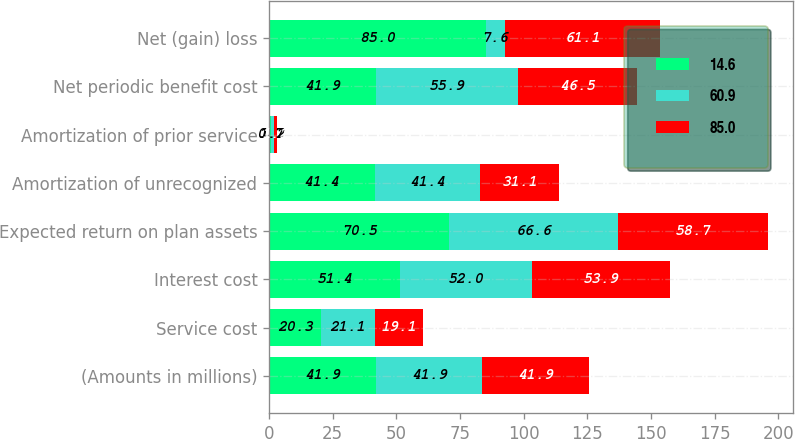<chart> <loc_0><loc_0><loc_500><loc_500><stacked_bar_chart><ecel><fcel>(Amounts in millions)<fcel>Service cost<fcel>Interest cost<fcel>Expected return on plan assets<fcel>Amortization of unrecognized<fcel>Amortization of prior service<fcel>Net periodic benefit cost<fcel>Net (gain) loss<nl><fcel>14.6<fcel>41.9<fcel>20.3<fcel>51.4<fcel>70.5<fcel>41.4<fcel>0.7<fcel>41.9<fcel>85<nl><fcel>60.9<fcel>41.9<fcel>21.1<fcel>52<fcel>66.6<fcel>41.4<fcel>1.2<fcel>55.9<fcel>7.6<nl><fcel>85<fcel>41.9<fcel>19.1<fcel>53.9<fcel>58.7<fcel>31.1<fcel>1.1<fcel>46.5<fcel>61.1<nl></chart> 